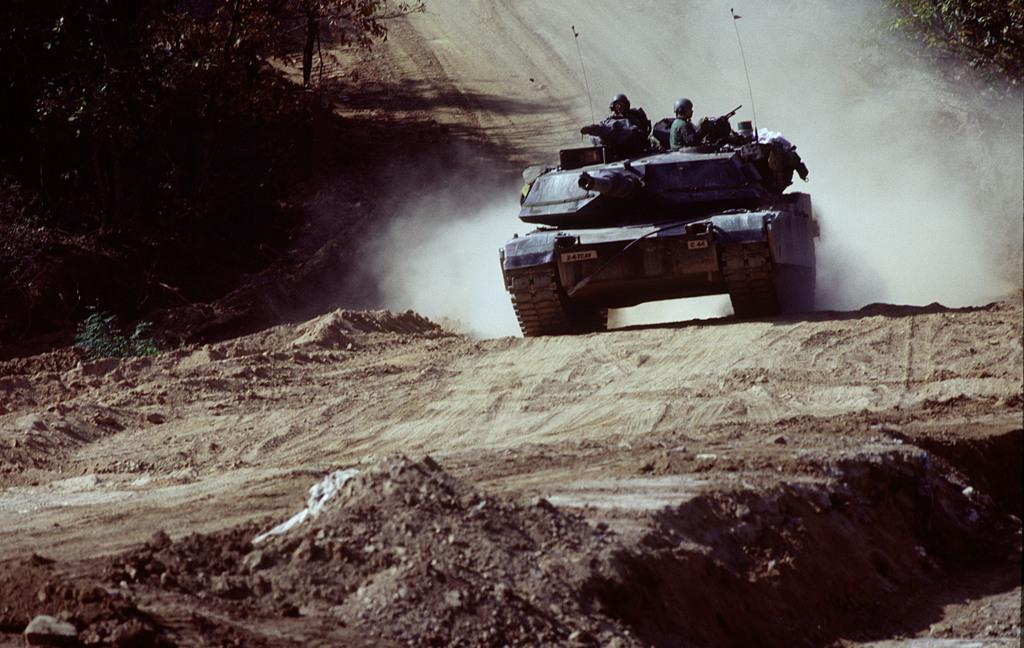What is the main subject of the image? The main subject of the image is a military tank. What is the tank doing in the image? The tank is running on the ground in the image. What can be seen coming out of the tank in the image? There is white smoke visible in the image. What type of vegetation is on the left side of the image? There are trees on the left side of the image. What is the tendency of the bear in the image? There is no bear present in the image, so it is not possible to determine its tendency. 